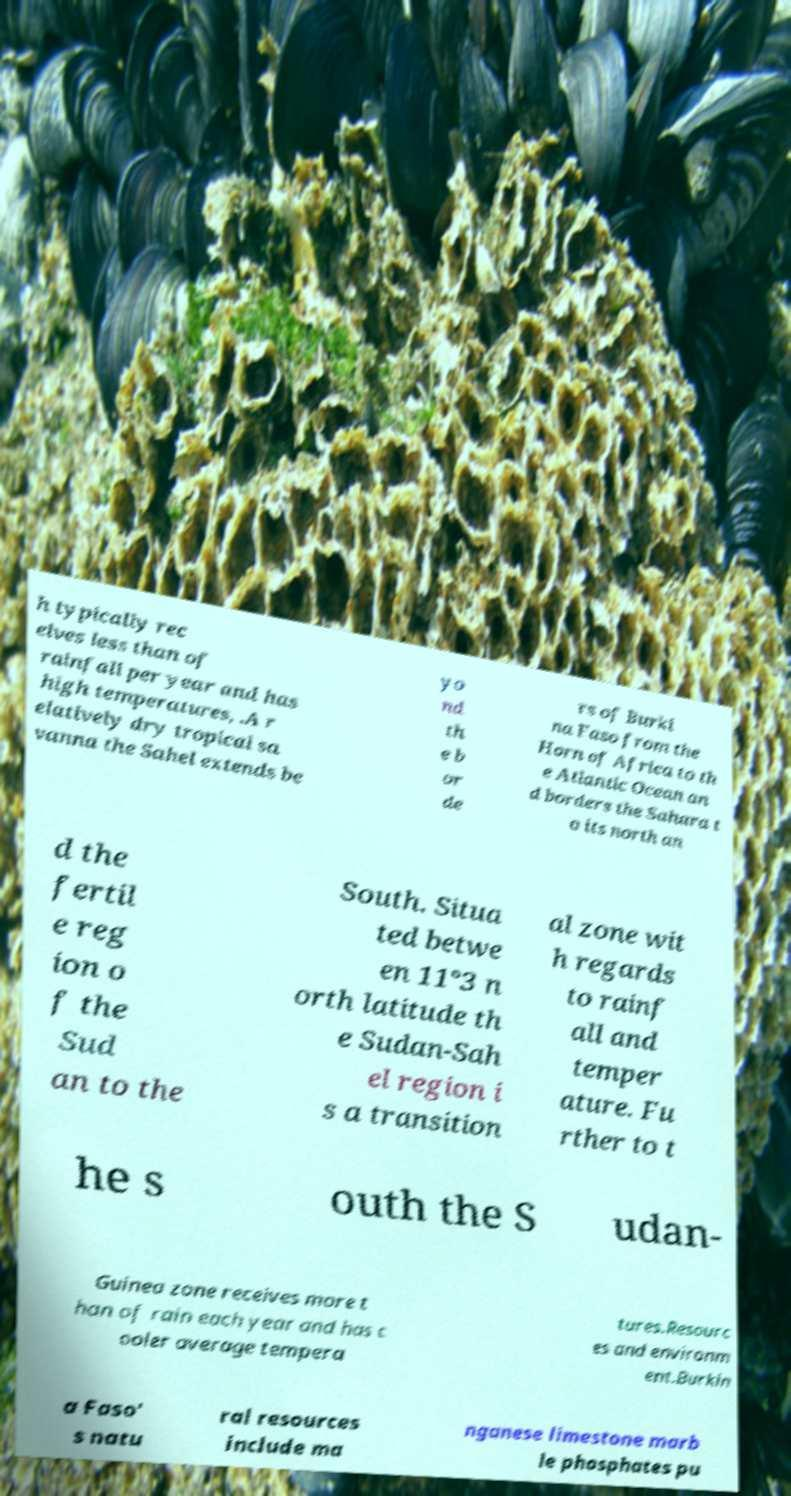Please identify and transcribe the text found in this image. h typically rec eives less than of rainfall per year and has high temperatures, .A r elatively dry tropical sa vanna the Sahel extends be yo nd th e b or de rs of Burki na Faso from the Horn of Africa to th e Atlantic Ocean an d borders the Sahara t o its north an d the fertil e reg ion o f the Sud an to the South. Situa ted betwe en 11°3 n orth latitude th e Sudan-Sah el region i s a transition al zone wit h regards to rainf all and temper ature. Fu rther to t he s outh the S udan- Guinea zone receives more t han of rain each year and has c ooler average tempera tures.Resourc es and environm ent.Burkin a Faso' s natu ral resources include ma nganese limestone marb le phosphates pu 